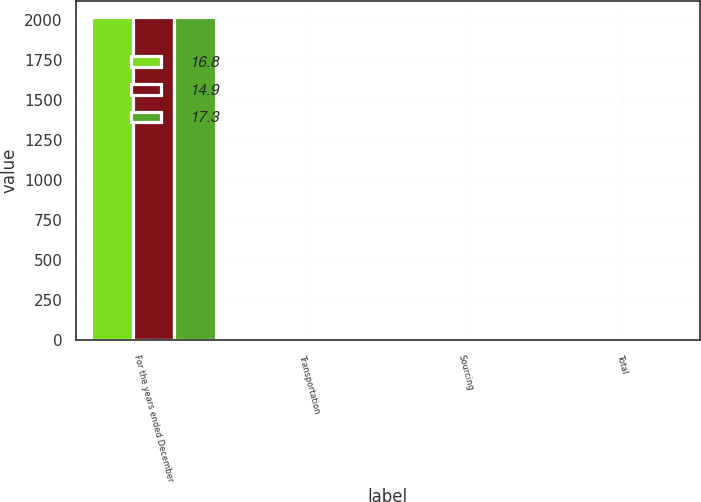<chart> <loc_0><loc_0><loc_500><loc_500><stacked_bar_chart><ecel><fcel>For the years ended December<fcel>Transportation<fcel>Sourcing<fcel>Total<nl><fcel>16.8<fcel>2016<fcel>18.4<fcel>8.5<fcel>17.3<nl><fcel>14.9<fcel>2015<fcel>17.9<fcel>8.1<fcel>16.8<nl><fcel>17.3<fcel>2014<fcel>15.9<fcel>7.5<fcel>14.9<nl></chart> 